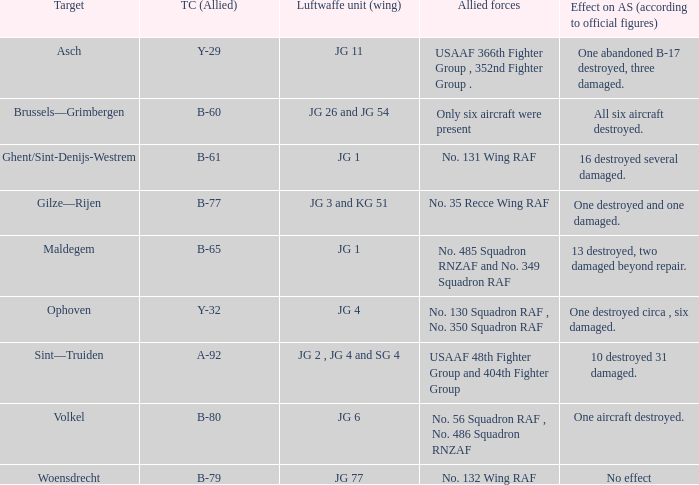What is the allied target code of the group that targetted ghent/sint-denijs-westrem? B-61. 